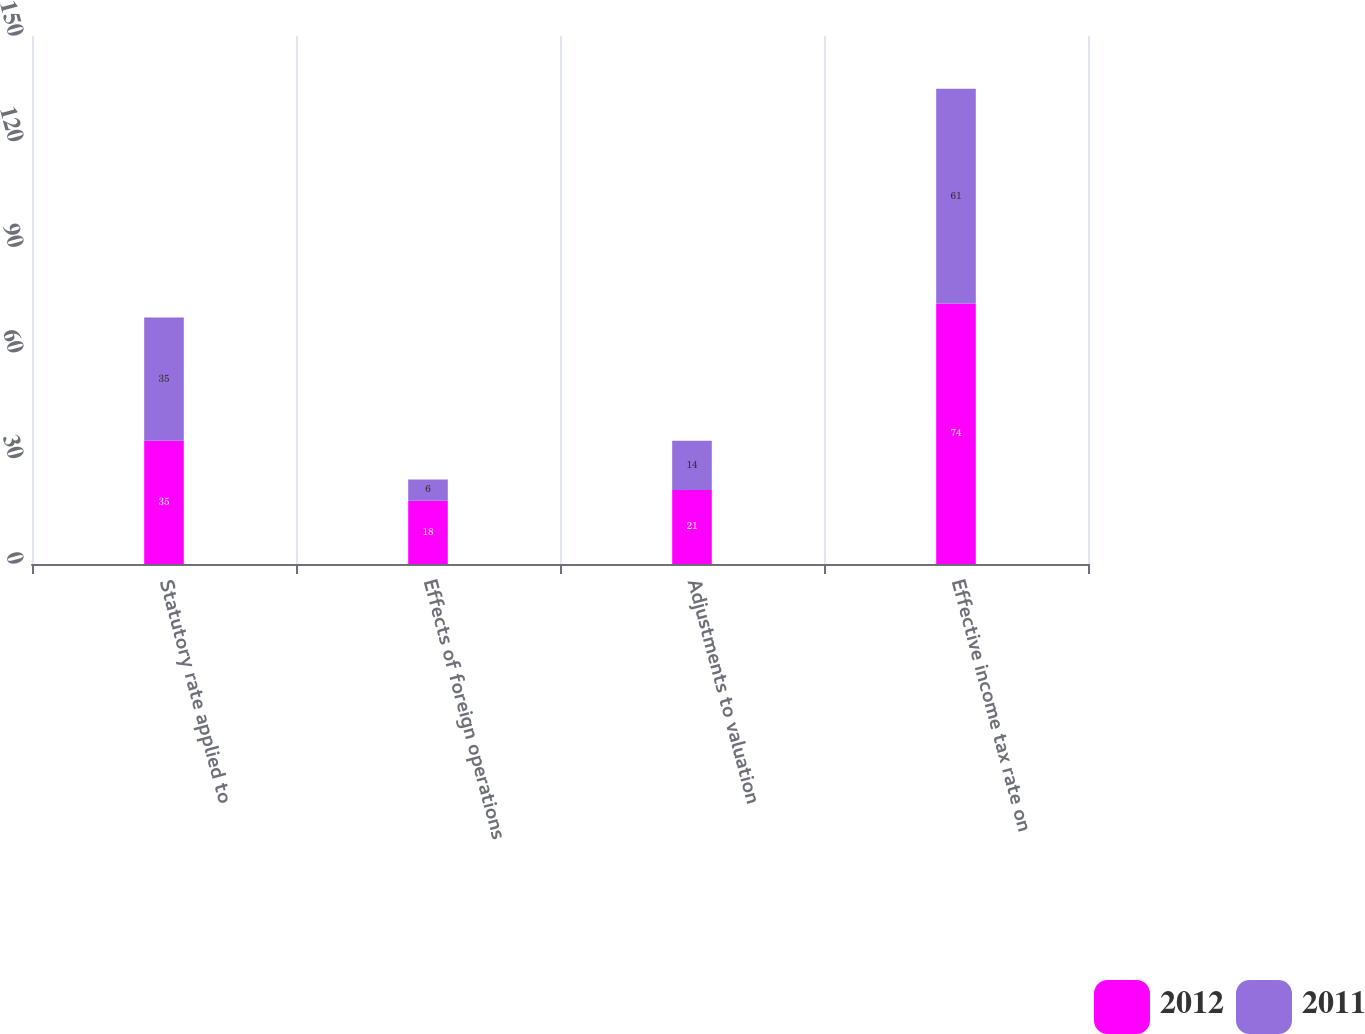<chart> <loc_0><loc_0><loc_500><loc_500><stacked_bar_chart><ecel><fcel>Statutory rate applied to<fcel>Effects of foreign operations<fcel>Adjustments to valuation<fcel>Effective income tax rate on<nl><fcel>2012<fcel>35<fcel>18<fcel>21<fcel>74<nl><fcel>2011<fcel>35<fcel>6<fcel>14<fcel>61<nl></chart> 